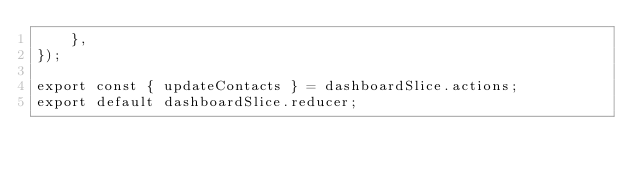Convert code to text. <code><loc_0><loc_0><loc_500><loc_500><_JavaScript_>    },
});

export const { updateContacts } = dashboardSlice.actions;
export default dashboardSlice.reducer;
</code> 